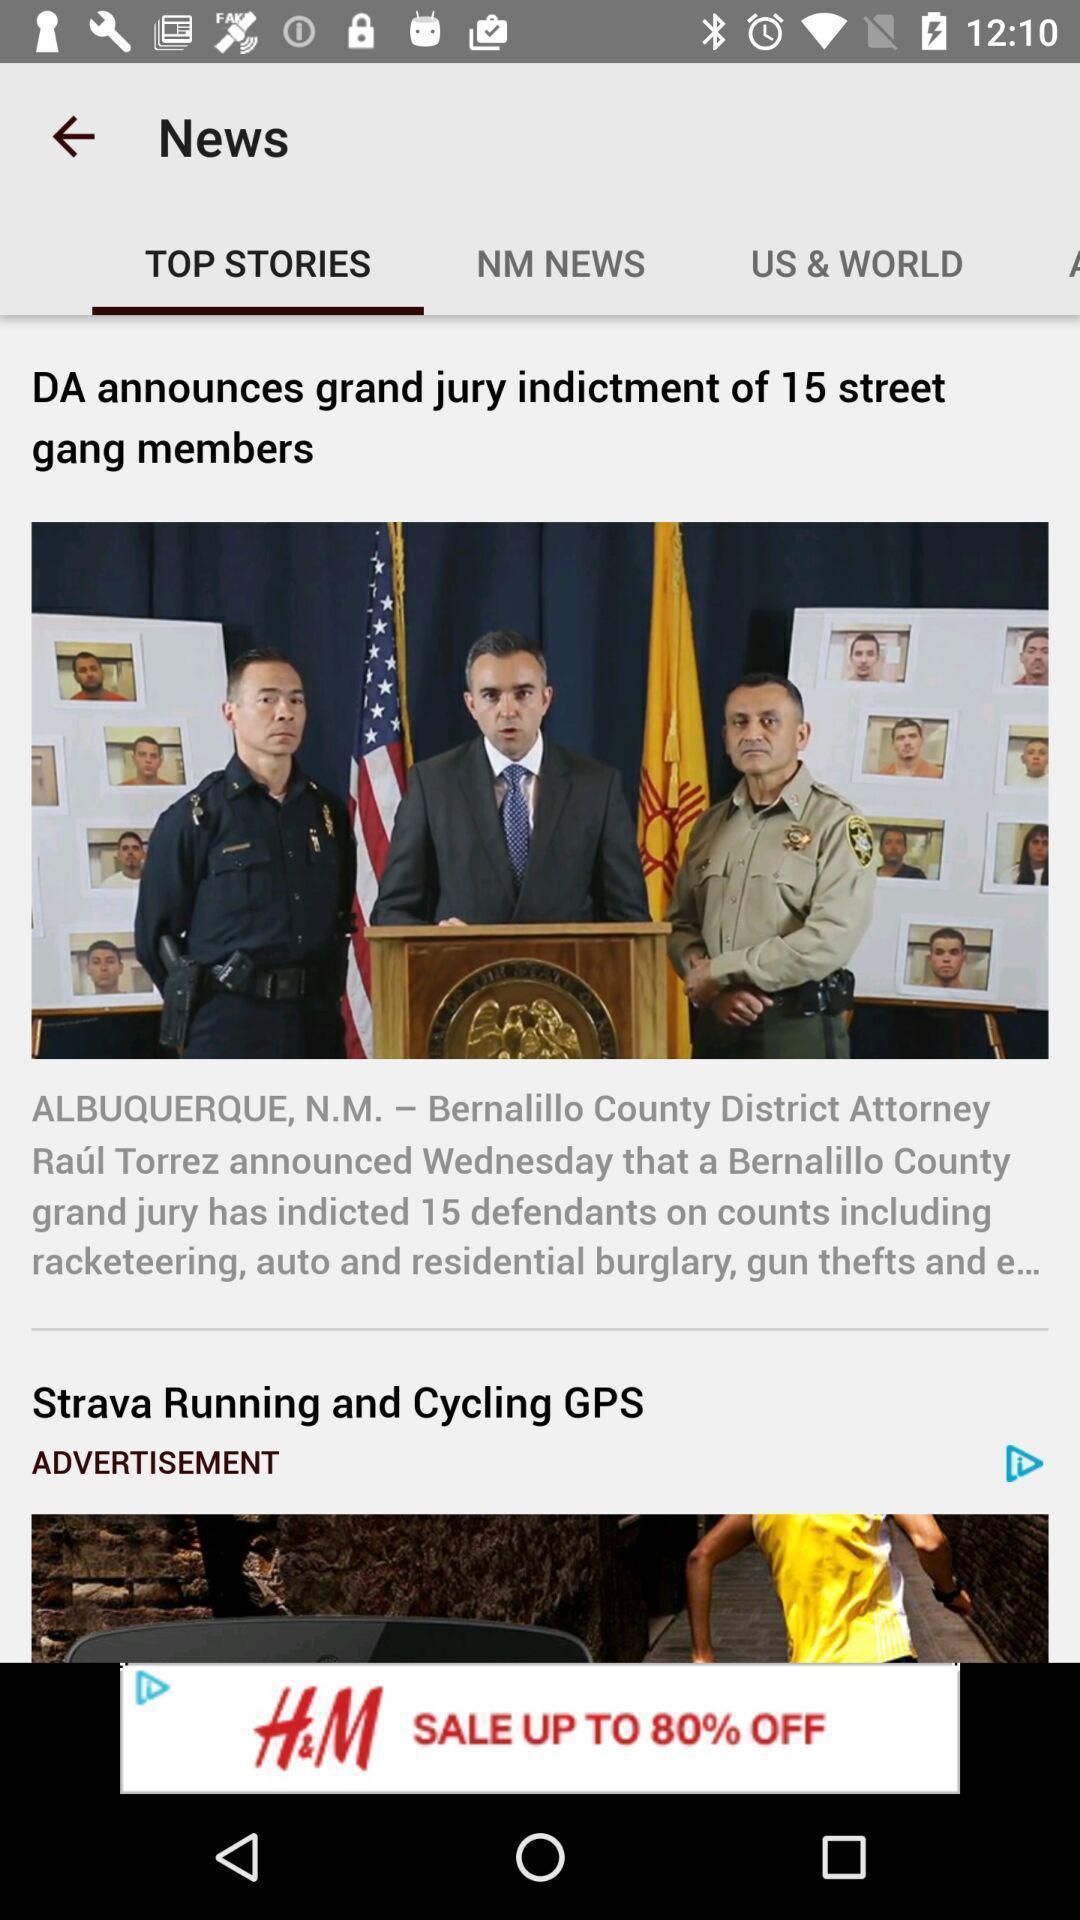What is the overall content of this screenshot? Top stories in a news app. 